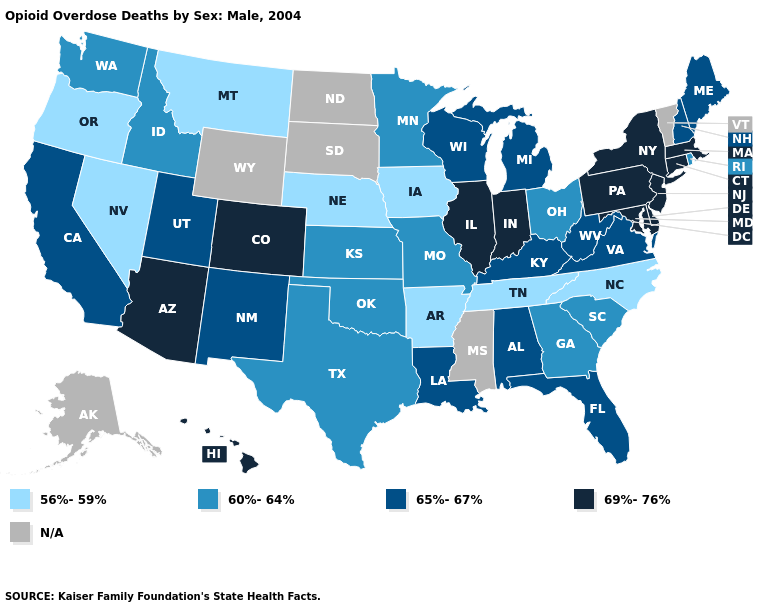Does Tennessee have the lowest value in the USA?
Short answer required. Yes. What is the value of Kansas?
Write a very short answer. 60%-64%. What is the value of Oklahoma?
Give a very brief answer. 60%-64%. What is the value of Virginia?
Be succinct. 65%-67%. Among the states that border Oklahoma , which have the lowest value?
Answer briefly. Arkansas. Name the states that have a value in the range 60%-64%?
Short answer required. Georgia, Idaho, Kansas, Minnesota, Missouri, Ohio, Oklahoma, Rhode Island, South Carolina, Texas, Washington. Is the legend a continuous bar?
Answer briefly. No. Among the states that border Michigan , does Wisconsin have the highest value?
Write a very short answer. No. What is the value of Mississippi?
Keep it brief. N/A. Name the states that have a value in the range 60%-64%?
Quick response, please. Georgia, Idaho, Kansas, Minnesota, Missouri, Ohio, Oklahoma, Rhode Island, South Carolina, Texas, Washington. What is the value of New Hampshire?
Short answer required. 65%-67%. Does Illinois have the highest value in the USA?
Keep it brief. Yes. What is the value of Maine?
Be succinct. 65%-67%. Which states have the highest value in the USA?
Quick response, please. Arizona, Colorado, Connecticut, Delaware, Hawaii, Illinois, Indiana, Maryland, Massachusetts, New Jersey, New York, Pennsylvania. 